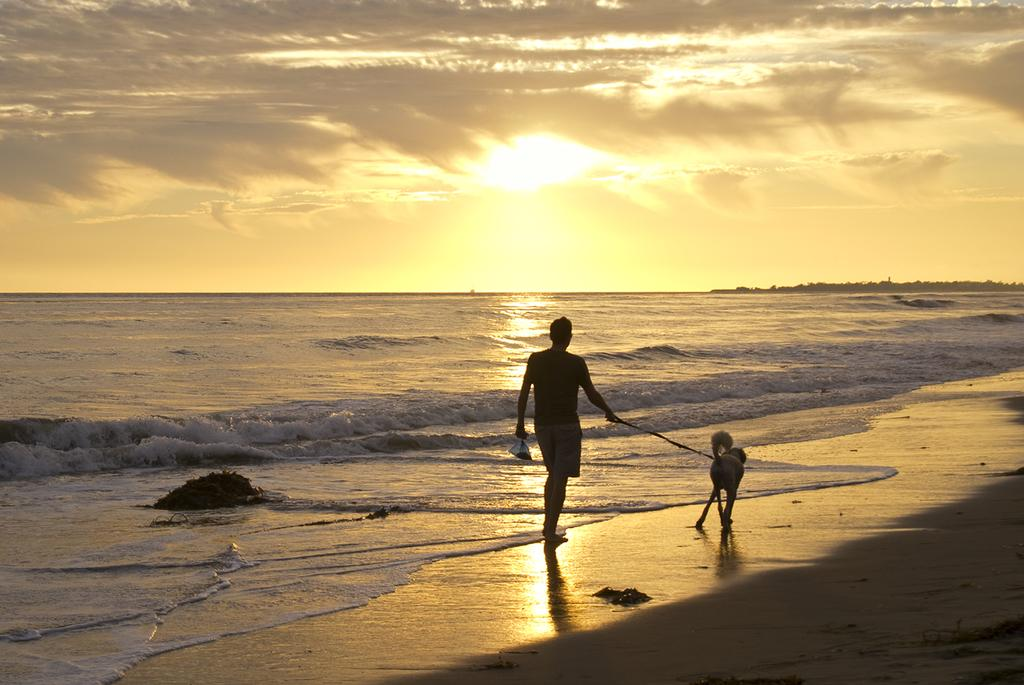Who is present in the image? There is a man in the image. What is the man doing in the image? The man is walking with a dog in the image. Where is the location of the image? The location is a beach. What can be seen in the background of the image? There is a sea visible in the image, and there is a sunrise in the sky. How many kittens are playing on the beach in the image? There are no kittens present in the image; it features a man walking with a dog on a beach. What is the cent value of the coin the man is holding in the image? There is no coin visible in the image, and the man is not holding anything in his hands. 